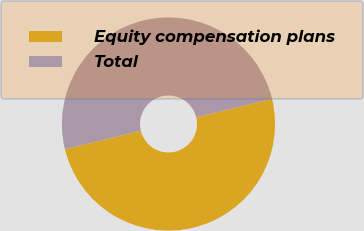Convert chart. <chart><loc_0><loc_0><loc_500><loc_500><pie_chart><fcel>Equity compensation plans<fcel>Total<nl><fcel>50.0%<fcel>50.0%<nl></chart> 